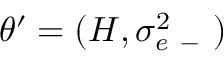<formula> <loc_0><loc_0><loc_500><loc_500>\theta ^ { \prime } = ( H , \sigma _ { e - } ^ { 2 } )</formula> 